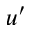<formula> <loc_0><loc_0><loc_500><loc_500>u ^ { \prime }</formula> 